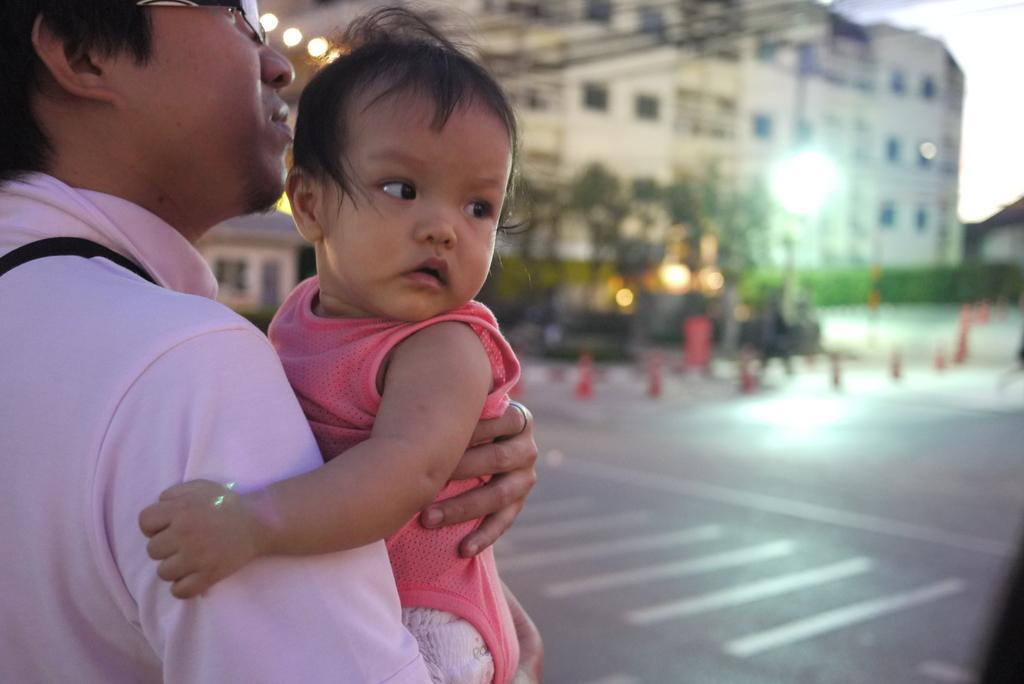Can you describe this image briefly? This image is clicked outside. There is a building at the top. There is the man on the left side. He is holding a baby in his hands. 